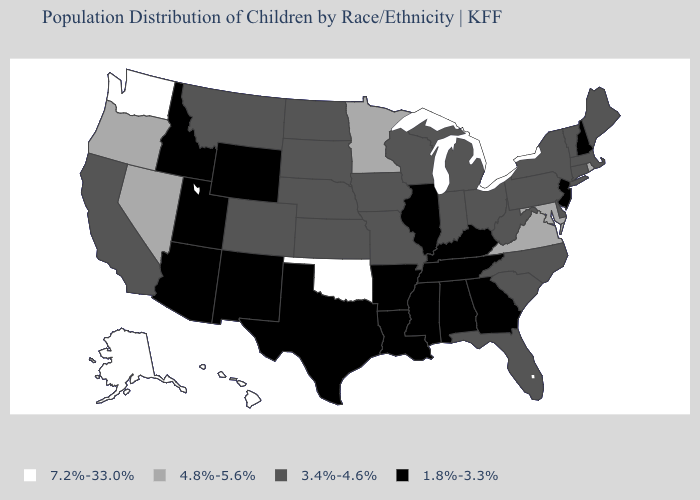What is the value of Wyoming?
Keep it brief. 1.8%-3.3%. Name the states that have a value in the range 7.2%-33.0%?
Answer briefly. Alaska, Hawaii, Oklahoma, Washington. Among the states that border North Carolina , which have the highest value?
Quick response, please. Virginia. Name the states that have a value in the range 3.4%-4.6%?
Short answer required. California, Colorado, Connecticut, Delaware, Florida, Indiana, Iowa, Kansas, Maine, Massachusetts, Michigan, Missouri, Montana, Nebraska, New York, North Carolina, North Dakota, Ohio, Pennsylvania, South Carolina, South Dakota, Vermont, West Virginia, Wisconsin. Name the states that have a value in the range 3.4%-4.6%?
Quick response, please. California, Colorado, Connecticut, Delaware, Florida, Indiana, Iowa, Kansas, Maine, Massachusetts, Michigan, Missouri, Montana, Nebraska, New York, North Carolina, North Dakota, Ohio, Pennsylvania, South Carolina, South Dakota, Vermont, West Virginia, Wisconsin. Among the states that border Oklahoma , which have the lowest value?
Quick response, please. Arkansas, New Mexico, Texas. Among the states that border South Carolina , which have the lowest value?
Be succinct. Georgia. Name the states that have a value in the range 4.8%-5.6%?
Write a very short answer. Maryland, Minnesota, Nevada, Oregon, Rhode Island, Virginia. Among the states that border Colorado , does Oklahoma have the highest value?
Keep it brief. Yes. Name the states that have a value in the range 1.8%-3.3%?
Quick response, please. Alabama, Arizona, Arkansas, Georgia, Idaho, Illinois, Kentucky, Louisiana, Mississippi, New Hampshire, New Jersey, New Mexico, Tennessee, Texas, Utah, Wyoming. Which states have the lowest value in the USA?
Be succinct. Alabama, Arizona, Arkansas, Georgia, Idaho, Illinois, Kentucky, Louisiana, Mississippi, New Hampshire, New Jersey, New Mexico, Tennessee, Texas, Utah, Wyoming. Name the states that have a value in the range 4.8%-5.6%?
Give a very brief answer. Maryland, Minnesota, Nevada, Oregon, Rhode Island, Virginia. What is the value of Nebraska?
Concise answer only. 3.4%-4.6%. What is the value of Maine?
Be succinct. 3.4%-4.6%. What is the value of Florida?
Give a very brief answer. 3.4%-4.6%. 